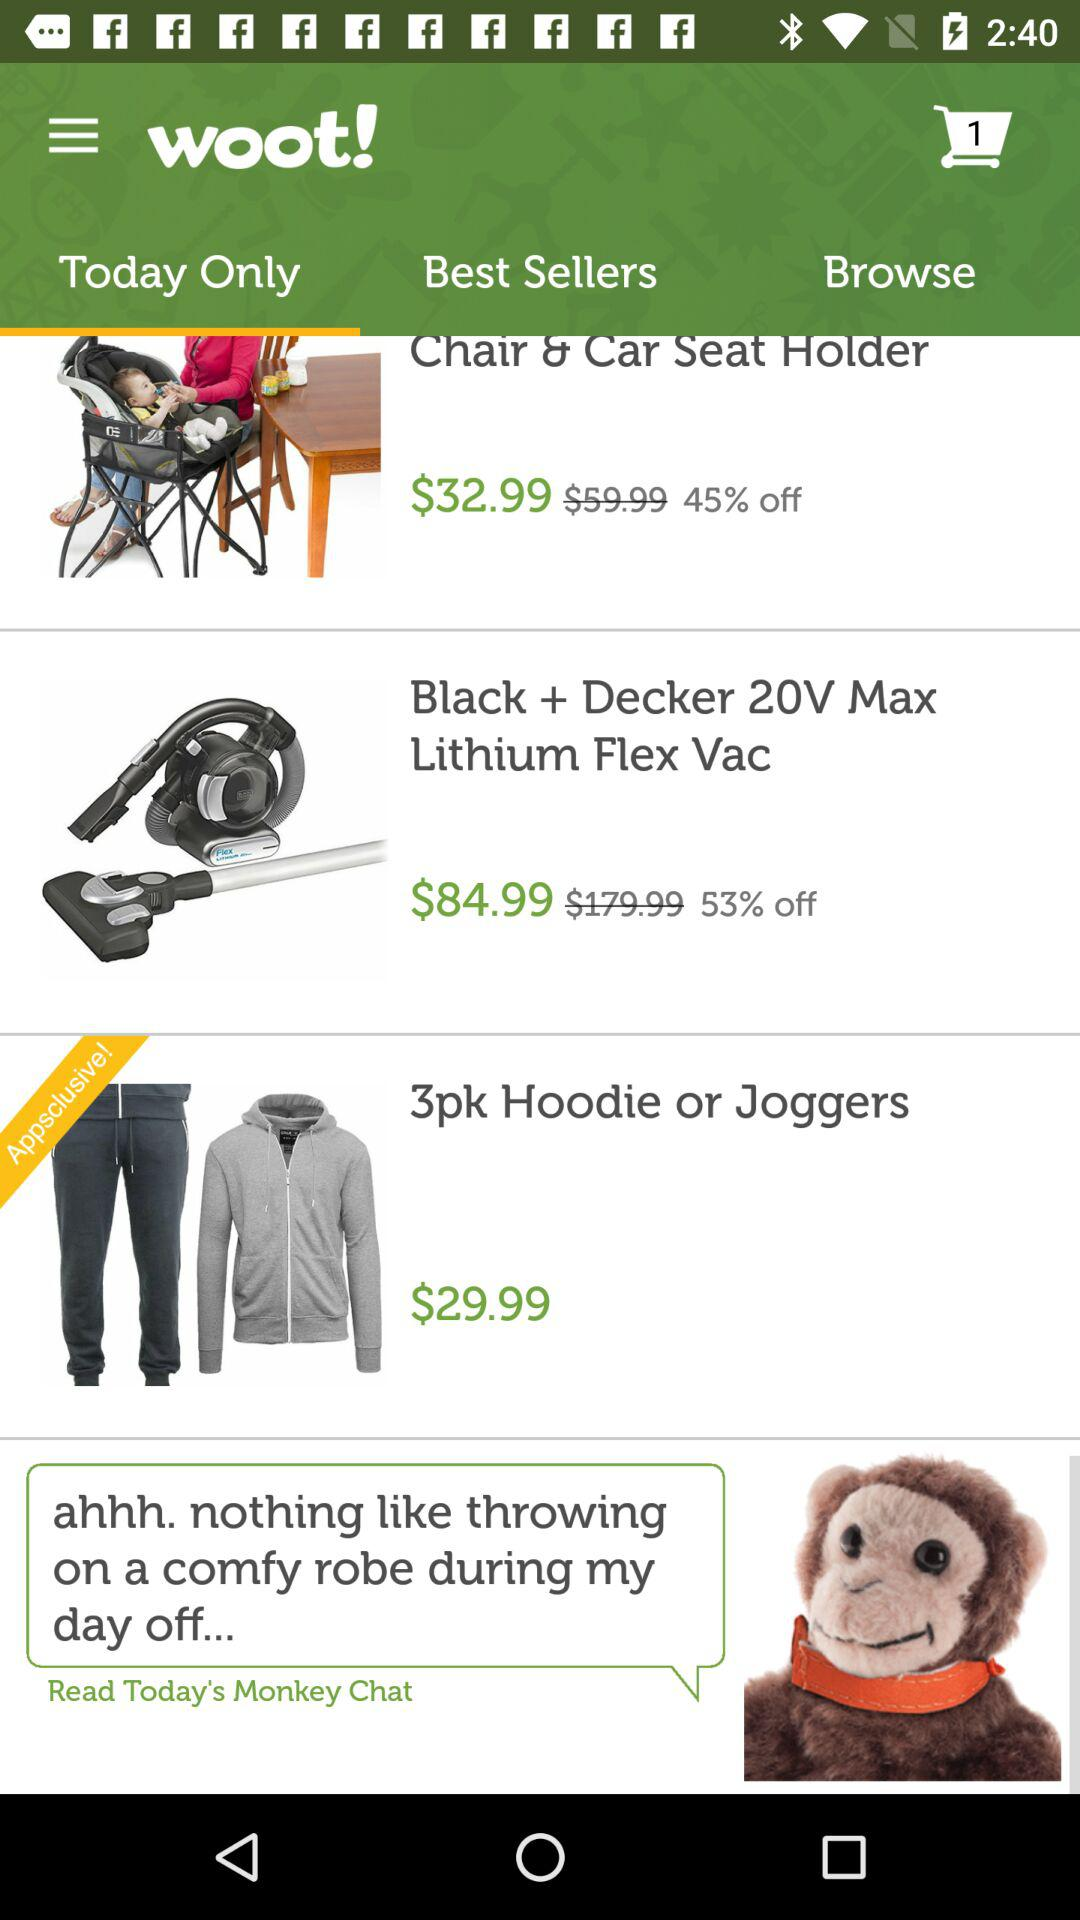What is the application name? The application name is "woot!". 